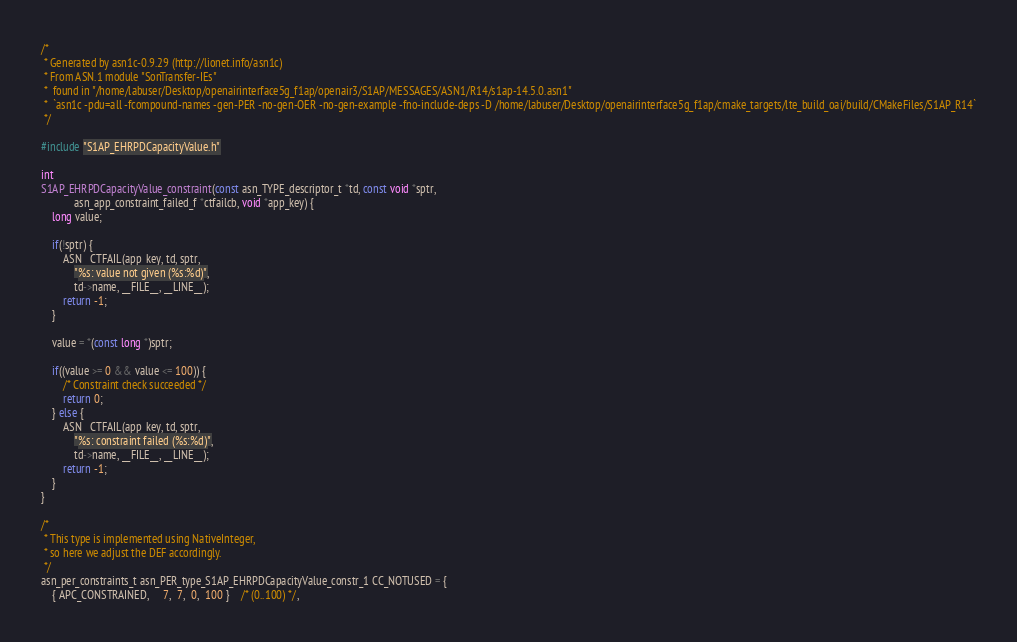<code> <loc_0><loc_0><loc_500><loc_500><_C_>/*
 * Generated by asn1c-0.9.29 (http://lionet.info/asn1c)
 * From ASN.1 module "SonTransfer-IEs"
 * 	found in "/home/labuser/Desktop/openairinterface5g_f1ap/openair3/S1AP/MESSAGES/ASN1/R14/s1ap-14.5.0.asn1"
 * 	`asn1c -pdu=all -fcompound-names -gen-PER -no-gen-OER -no-gen-example -fno-include-deps -D /home/labuser/Desktop/openairinterface5g_f1ap/cmake_targets/lte_build_oai/build/CMakeFiles/S1AP_R14`
 */

#include "S1AP_EHRPDCapacityValue.h"

int
S1AP_EHRPDCapacityValue_constraint(const asn_TYPE_descriptor_t *td, const void *sptr,
			asn_app_constraint_failed_f *ctfailcb, void *app_key) {
	long value;
	
	if(!sptr) {
		ASN__CTFAIL(app_key, td, sptr,
			"%s: value not given (%s:%d)",
			td->name, __FILE__, __LINE__);
		return -1;
	}
	
	value = *(const long *)sptr;
	
	if((value >= 0 && value <= 100)) {
		/* Constraint check succeeded */
		return 0;
	} else {
		ASN__CTFAIL(app_key, td, sptr,
			"%s: constraint failed (%s:%d)",
			td->name, __FILE__, __LINE__);
		return -1;
	}
}

/*
 * This type is implemented using NativeInteger,
 * so here we adjust the DEF accordingly.
 */
asn_per_constraints_t asn_PER_type_S1AP_EHRPDCapacityValue_constr_1 CC_NOTUSED = {
	{ APC_CONSTRAINED,	 7,  7,  0,  100 }	/* (0..100) */,</code> 